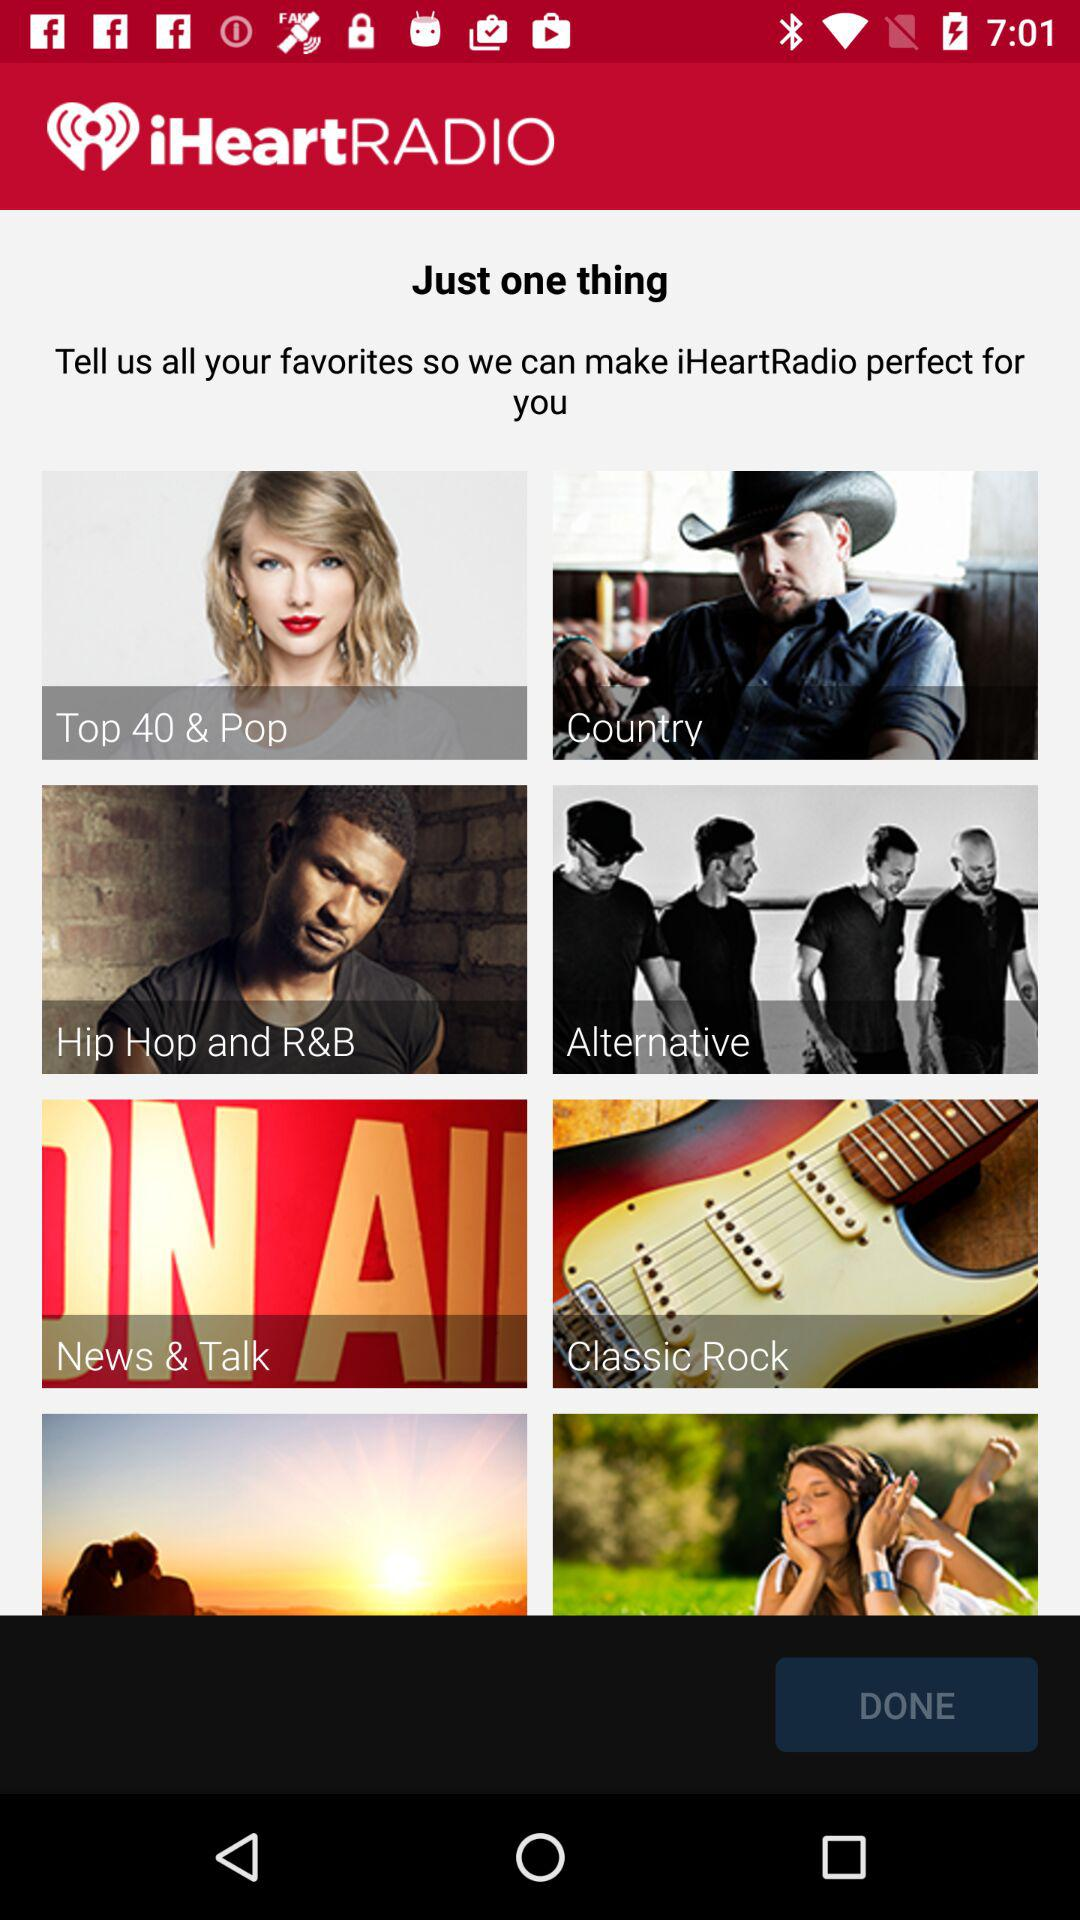What options are given on iHeartRADIO to set as favorites? The given options are: "Top 40 & Pop", "Country", "Hip Hop and R&B", "Alternative", "News & Talk" and "Classic Rock". 